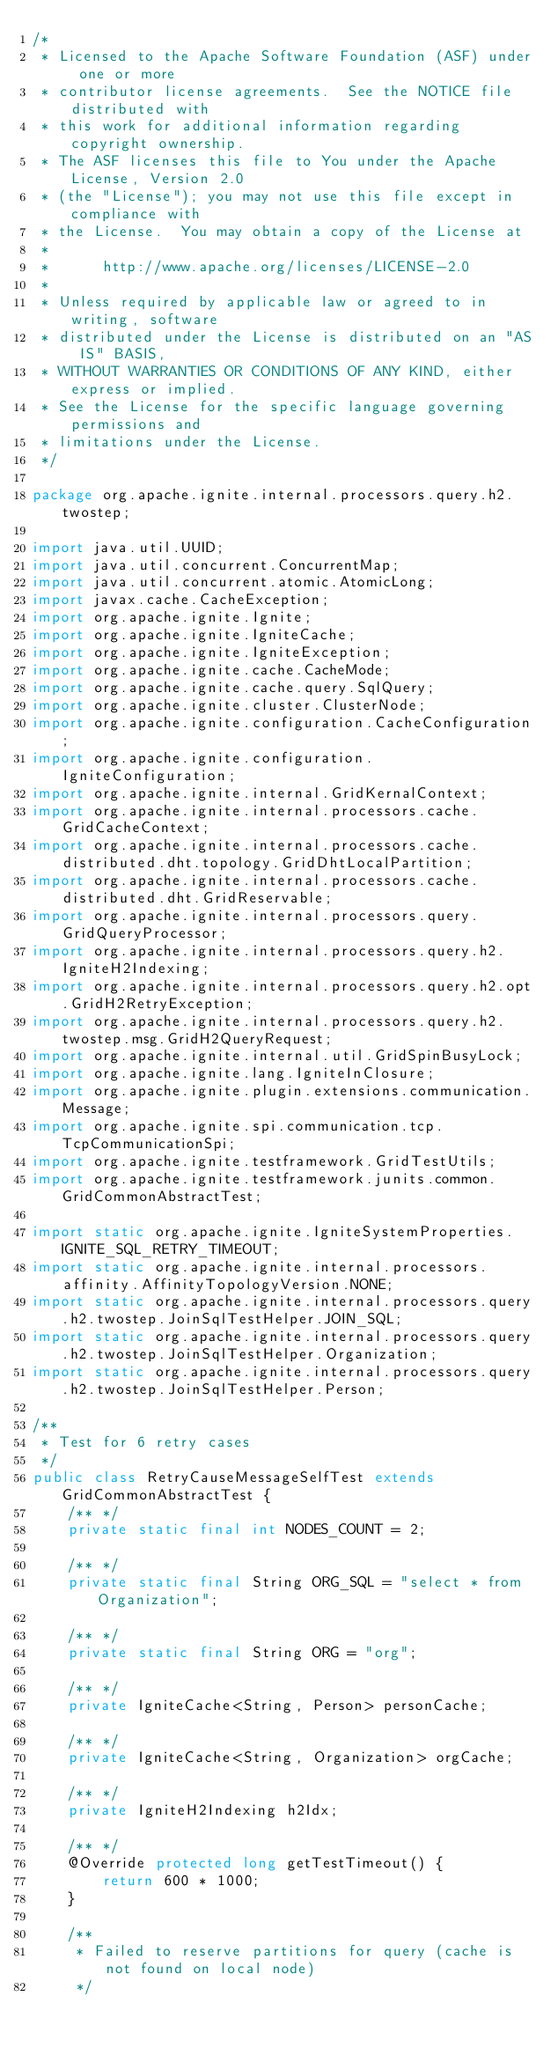Convert code to text. <code><loc_0><loc_0><loc_500><loc_500><_Java_>/*
 * Licensed to the Apache Software Foundation (ASF) under one or more
 * contributor license agreements.  See the NOTICE file distributed with
 * this work for additional information regarding copyright ownership.
 * The ASF licenses this file to You under the Apache License, Version 2.0
 * (the "License"); you may not use this file except in compliance with
 * the License.  You may obtain a copy of the License at
 *
 *      http://www.apache.org/licenses/LICENSE-2.0
 *
 * Unless required by applicable law or agreed to in writing, software
 * distributed under the License is distributed on an "AS IS" BASIS,
 * WITHOUT WARRANTIES OR CONDITIONS OF ANY KIND, either express or implied.
 * See the License for the specific language governing permissions and
 * limitations under the License.
 */

package org.apache.ignite.internal.processors.query.h2.twostep;

import java.util.UUID;
import java.util.concurrent.ConcurrentMap;
import java.util.concurrent.atomic.AtomicLong;
import javax.cache.CacheException;
import org.apache.ignite.Ignite;
import org.apache.ignite.IgniteCache;
import org.apache.ignite.IgniteException;
import org.apache.ignite.cache.CacheMode;
import org.apache.ignite.cache.query.SqlQuery;
import org.apache.ignite.cluster.ClusterNode;
import org.apache.ignite.configuration.CacheConfiguration;
import org.apache.ignite.configuration.IgniteConfiguration;
import org.apache.ignite.internal.GridKernalContext;
import org.apache.ignite.internal.processors.cache.GridCacheContext;
import org.apache.ignite.internal.processors.cache.distributed.dht.topology.GridDhtLocalPartition;
import org.apache.ignite.internal.processors.cache.distributed.dht.GridReservable;
import org.apache.ignite.internal.processors.query.GridQueryProcessor;
import org.apache.ignite.internal.processors.query.h2.IgniteH2Indexing;
import org.apache.ignite.internal.processors.query.h2.opt.GridH2RetryException;
import org.apache.ignite.internal.processors.query.h2.twostep.msg.GridH2QueryRequest;
import org.apache.ignite.internal.util.GridSpinBusyLock;
import org.apache.ignite.lang.IgniteInClosure;
import org.apache.ignite.plugin.extensions.communication.Message;
import org.apache.ignite.spi.communication.tcp.TcpCommunicationSpi;
import org.apache.ignite.testframework.GridTestUtils;
import org.apache.ignite.testframework.junits.common.GridCommonAbstractTest;

import static org.apache.ignite.IgniteSystemProperties.IGNITE_SQL_RETRY_TIMEOUT;
import static org.apache.ignite.internal.processors.affinity.AffinityTopologyVersion.NONE;
import static org.apache.ignite.internal.processors.query.h2.twostep.JoinSqlTestHelper.JOIN_SQL;
import static org.apache.ignite.internal.processors.query.h2.twostep.JoinSqlTestHelper.Organization;
import static org.apache.ignite.internal.processors.query.h2.twostep.JoinSqlTestHelper.Person;

/**
 * Test for 6 retry cases
 */
public class RetryCauseMessageSelfTest extends GridCommonAbstractTest {
    /** */
    private static final int NODES_COUNT = 2;

    /** */
    private static final String ORG_SQL = "select * from Organization";

    /** */
    private static final String ORG = "org";

    /** */
    private IgniteCache<String, Person> personCache;

    /** */
    private IgniteCache<String, Organization> orgCache;

    /** */
    private IgniteH2Indexing h2Idx;

    /** */
    @Override protected long getTestTimeout() {
        return 600 * 1000;
    }

    /**
     * Failed to reserve partitions for query (cache is not found on local node)
     */</code> 